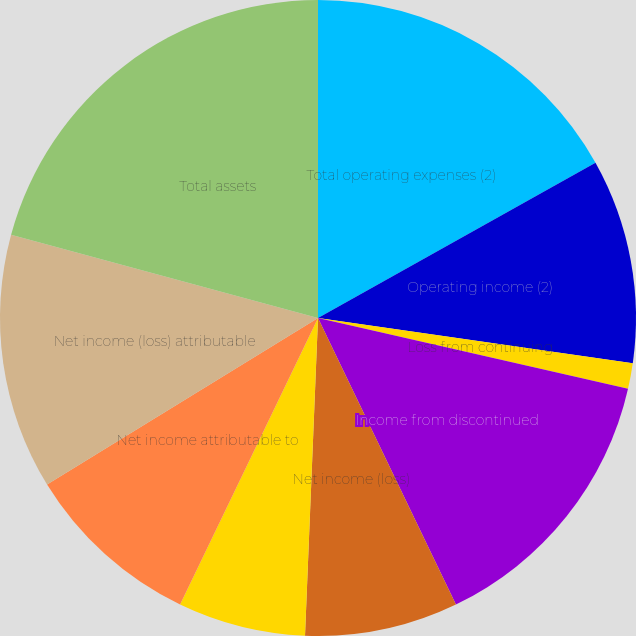<chart> <loc_0><loc_0><loc_500><loc_500><pie_chart><fcel>Total operating expenses (2)<fcel>Operating income (2)<fcel>Loss from continuing<fcel>Income from discontinued<fcel>Net income (loss)<fcel>Net (income) loss attributable<fcel>Net income attributable to<fcel>Net income (loss) attributable<fcel>Total assets<nl><fcel>16.88%<fcel>10.39%<fcel>1.3%<fcel>14.29%<fcel>7.79%<fcel>6.49%<fcel>9.09%<fcel>12.99%<fcel>20.78%<nl></chart> 